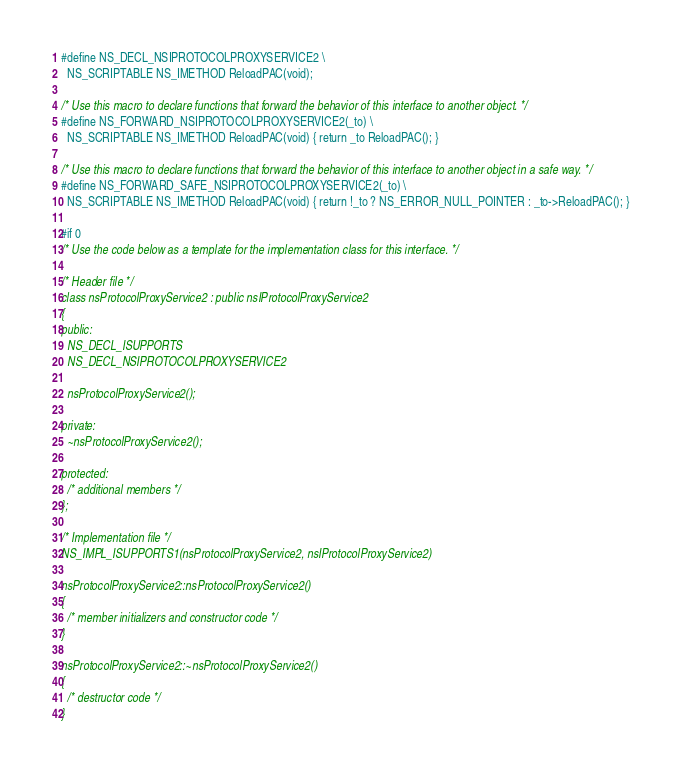<code> <loc_0><loc_0><loc_500><loc_500><_C_>#define NS_DECL_NSIPROTOCOLPROXYSERVICE2 \
  NS_SCRIPTABLE NS_IMETHOD ReloadPAC(void); 

/* Use this macro to declare functions that forward the behavior of this interface to another object. */
#define NS_FORWARD_NSIPROTOCOLPROXYSERVICE2(_to) \
  NS_SCRIPTABLE NS_IMETHOD ReloadPAC(void) { return _to ReloadPAC(); } 

/* Use this macro to declare functions that forward the behavior of this interface to another object in a safe way. */
#define NS_FORWARD_SAFE_NSIPROTOCOLPROXYSERVICE2(_to) \
  NS_SCRIPTABLE NS_IMETHOD ReloadPAC(void) { return !_to ? NS_ERROR_NULL_POINTER : _to->ReloadPAC(); } 

#if 0
/* Use the code below as a template for the implementation class for this interface. */

/* Header file */
class nsProtocolProxyService2 : public nsIProtocolProxyService2
{
public:
  NS_DECL_ISUPPORTS
  NS_DECL_NSIPROTOCOLPROXYSERVICE2

  nsProtocolProxyService2();

private:
  ~nsProtocolProxyService2();

protected:
  /* additional members */
};

/* Implementation file */
NS_IMPL_ISUPPORTS1(nsProtocolProxyService2, nsIProtocolProxyService2)

nsProtocolProxyService2::nsProtocolProxyService2()
{
  /* member initializers and constructor code */
}

nsProtocolProxyService2::~nsProtocolProxyService2()
{
  /* destructor code */
}
</code> 